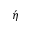Convert formula to latex. <formula><loc_0><loc_0><loc_500><loc_500>\acute { \eta }</formula> 